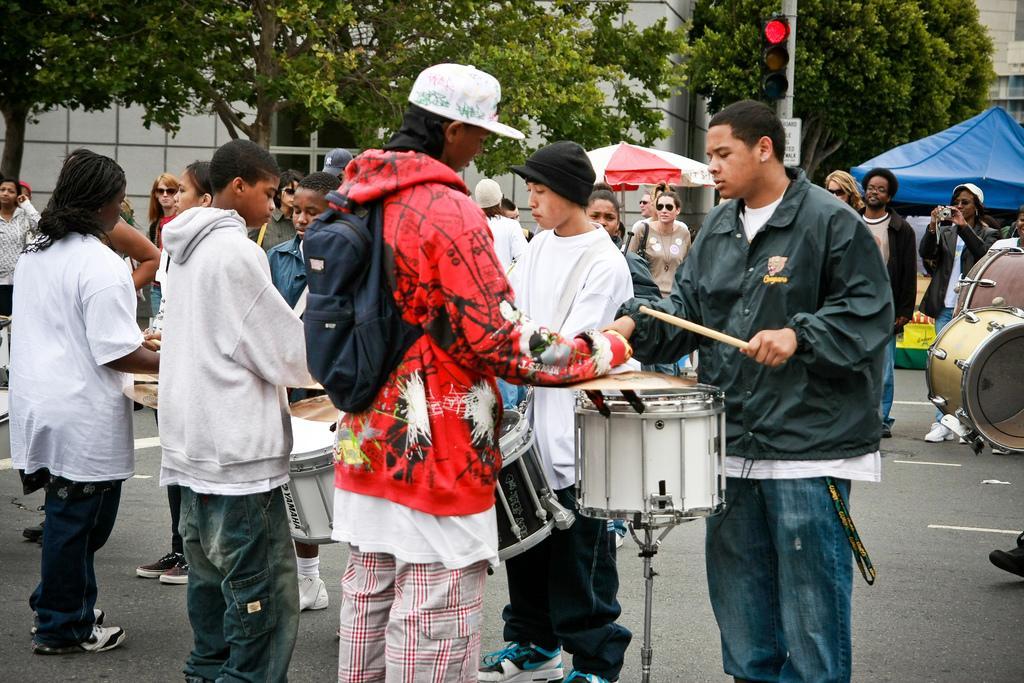Could you give a brief overview of what you see in this image? In this image i can see a group of people are standing on the road and playing drums. I can also see there is a tree and a building. 